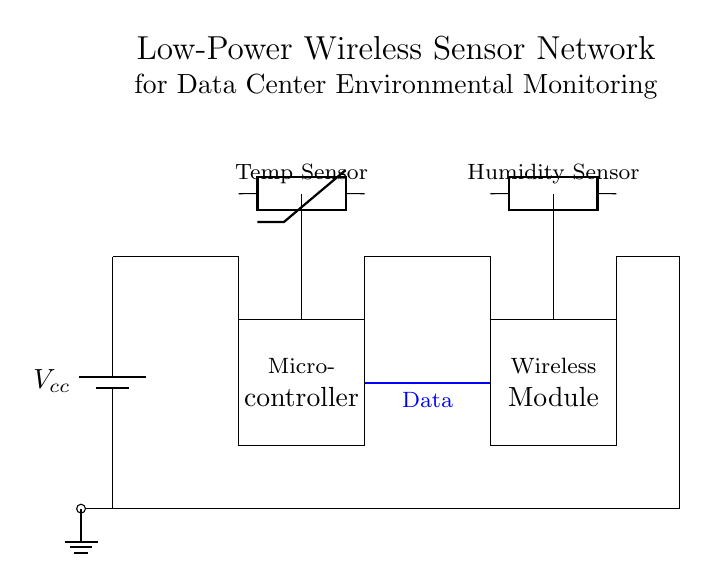What is the main power supply voltage? The main power supply is labeled as Vcc, which typically represents a positive voltage value in circuits, but the exact value is not specified. Generally, it could be a common voltage like 5V or 3.3V.
Answer: Vcc What type of microcontroller is used? The diagram does not specify the exact model of the microcontroller; it is simply represented by a rectangular block labeled "Microcontroller." It's likely a low-power variant suitable for sensor applications.
Answer: Microcontroller How many sensors are present in the circuit? There are two sensors in the circuit: a temperature sensor represented as a thermistor and a humidity sensor represented as a generic sensor. Thus, both sensors are used to monitor environmental conditions.
Answer: Two What is the function of the wireless module? The wireless module is responsible for transmitting the data collected from the sensors to a remote location for monitoring and analysis, facilitating wireless communication in the sensor network.
Answer: Transmit data What is the relationship between the temperature sensor and the microcontroller? The temperature sensor is connected to the microcontroller, which receives and processes the temperature data. The connection indicates that the microcontroller will use this data for further action, possibly to send it via the wireless module.
Answer: Data connection Which components are powered by the main power supply? The microcontroller, wireless module, temperature sensor, and humidity sensor are all connected to the main power supply, indicating they rely on this voltage for operation.
Answer: All components 